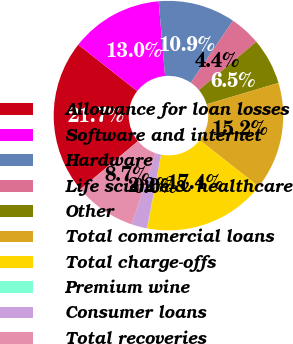Convert chart. <chart><loc_0><loc_0><loc_500><loc_500><pie_chart><fcel>Allowance for loan losses<fcel>Software and internet<fcel>Hardware<fcel>Life science & healthcare<fcel>Other<fcel>Total commercial loans<fcel>Total charge-offs<fcel>Premium wine<fcel>Consumer loans<fcel>Total recoveries<nl><fcel>21.7%<fcel>13.03%<fcel>10.87%<fcel>4.37%<fcel>6.53%<fcel>15.2%<fcel>17.37%<fcel>0.03%<fcel>2.2%<fcel>8.7%<nl></chart> 